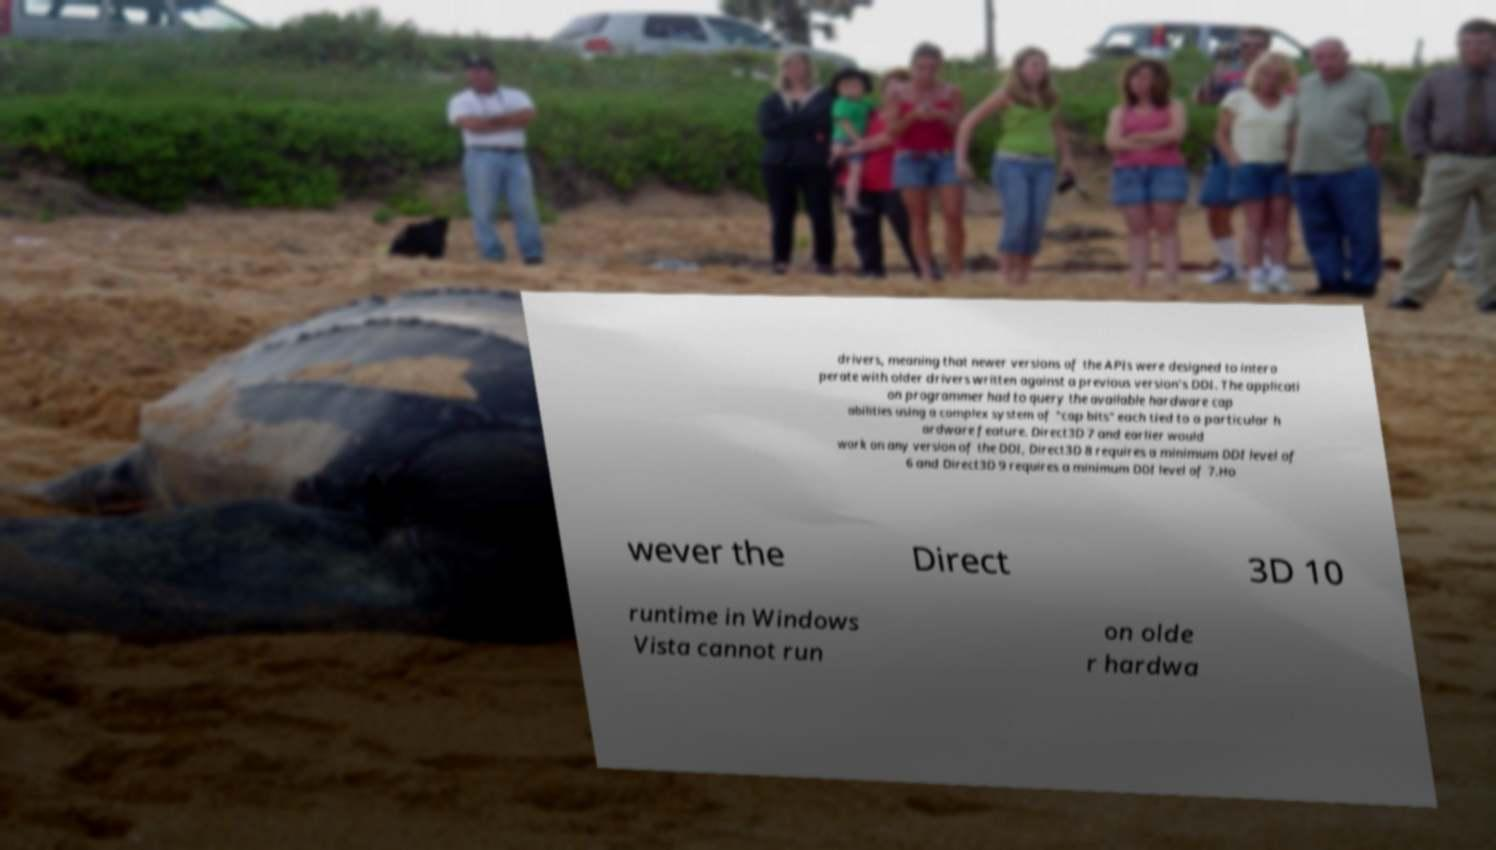Please identify and transcribe the text found in this image. drivers, meaning that newer versions of the APIs were designed to intero perate with older drivers written against a previous version's DDI. The applicati on programmer had to query the available hardware cap abilities using a complex system of "cap bits" each tied to a particular h ardware feature. Direct3D 7 and earlier would work on any version of the DDI, Direct3D 8 requires a minimum DDI level of 6 and Direct3D 9 requires a minimum DDI level of 7.Ho wever the Direct 3D 10 runtime in Windows Vista cannot run on olde r hardwa 